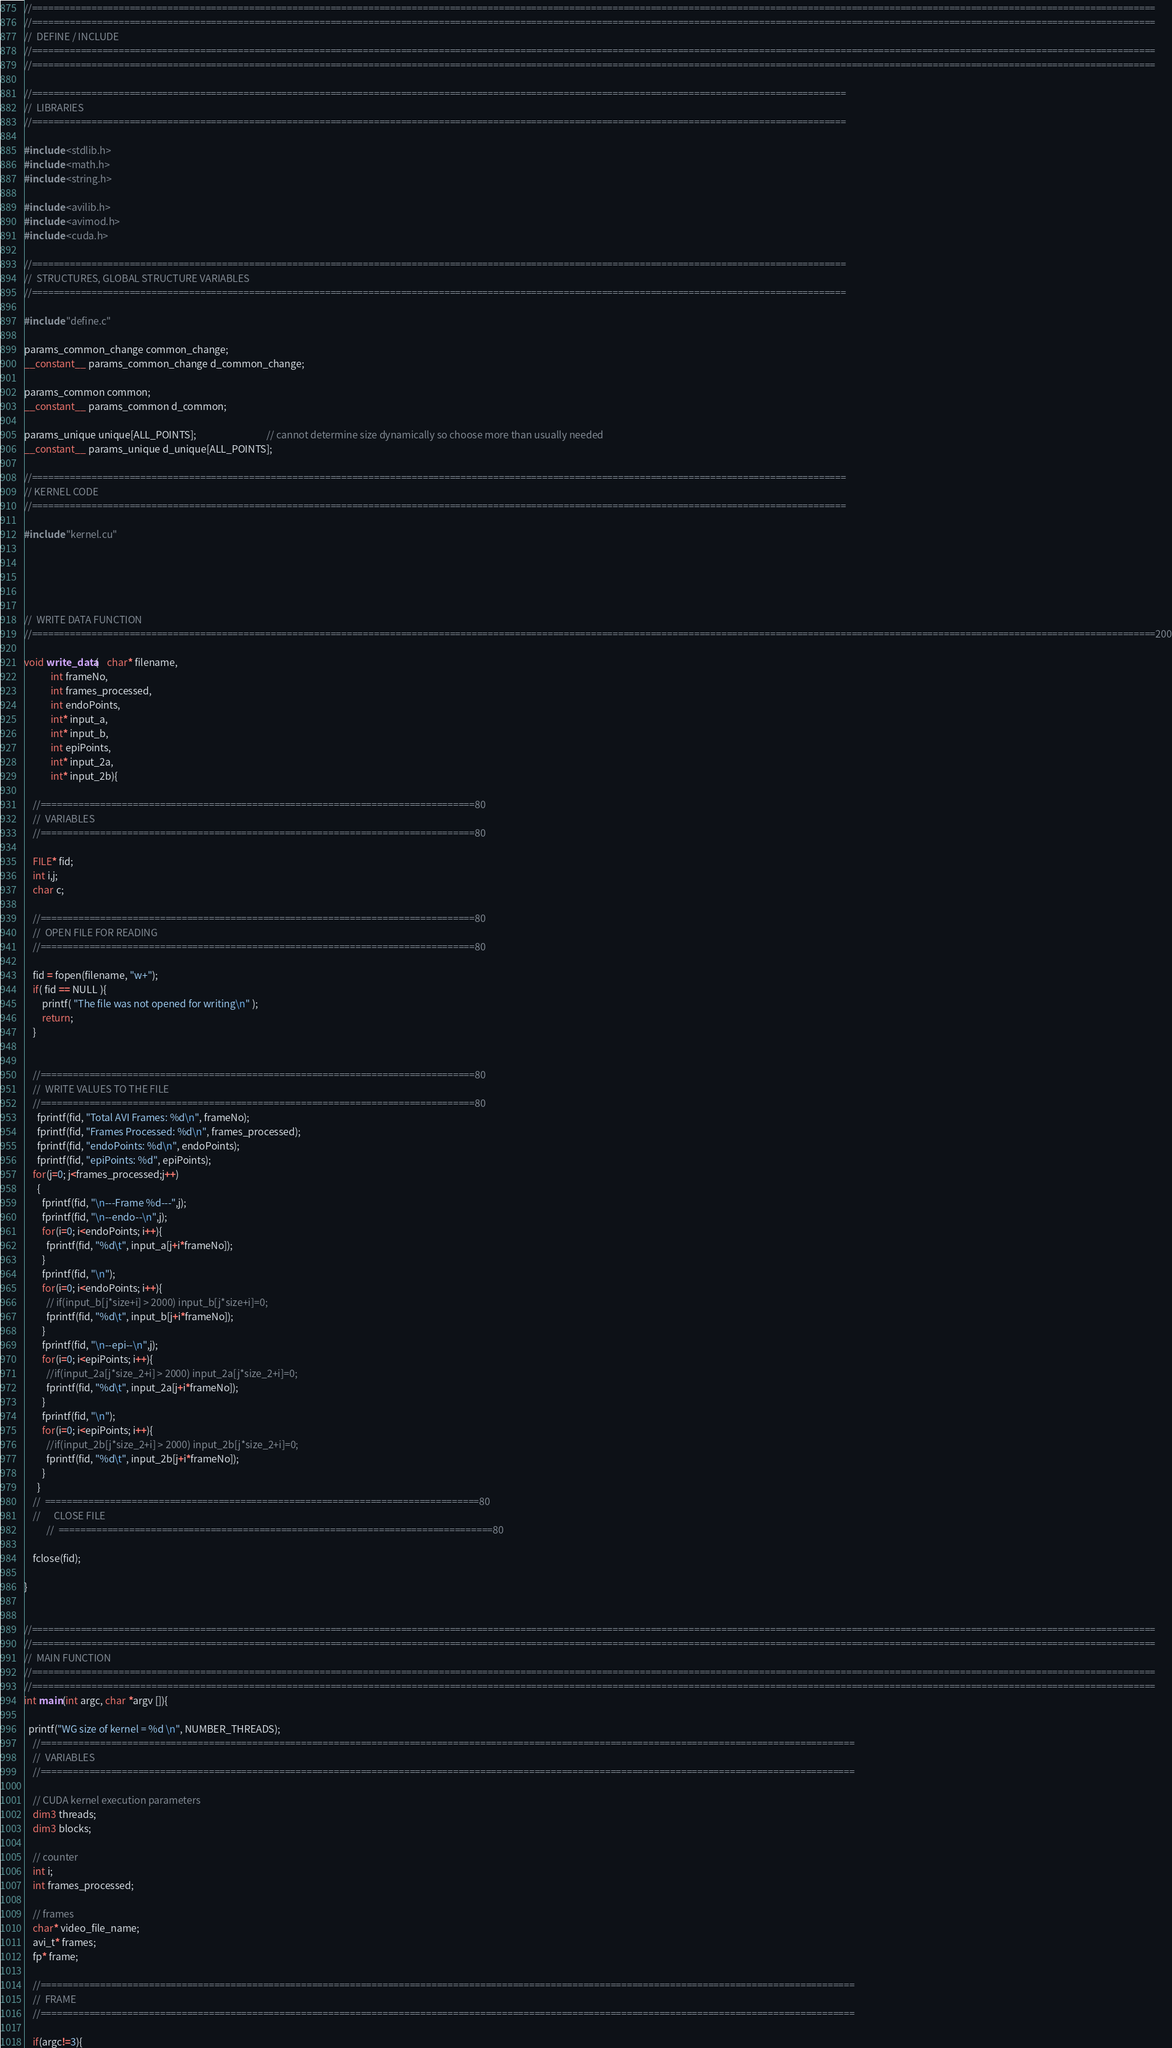Convert code to text. <code><loc_0><loc_0><loc_500><loc_500><_Cuda_>//===============================================================================================================================================================================================================
//===============================================================================================================================================================================================================
//	DEFINE / INCLUDE
//===============================================================================================================================================================================================================
//===============================================================================================================================================================================================================

//======================================================================================================================================================
//	LIBRARIES
//======================================================================================================================================================

#include <stdlib.h>
#include <math.h>
#include <string.h>

#include <avilib.h>
#include <avimod.h>
#include <cuda.h>

//======================================================================================================================================================
//	STRUCTURES, GLOBAL STRUCTURE VARIABLES
//======================================================================================================================================================

#include "define.c"

params_common_change common_change;
__constant__ params_common_change d_common_change;

params_common common;
__constant__ params_common d_common;

params_unique unique[ALL_POINTS];								// cannot determine size dynamically so choose more than usually needed
__constant__ params_unique d_unique[ALL_POINTS];

//======================================================================================================================================================
// KERNEL CODE
//======================================================================================================================================================

#include "kernel.cu"





//	WRITE DATA FUNCTION
//===============================================================================================================================================================================================================200

void write_data(	char* filename,
			int frameNo,
			int frames_processed,
			int endoPoints,
			int* input_a,
			int* input_b,
			int epiPoints,
			int* input_2a,
			int* input_2b){

	//================================================================================80
	//	VARIABLES
	//================================================================================80

	FILE* fid;
	int i,j;
	char c;

	//================================================================================80
	//	OPEN FILE FOR READING
	//================================================================================80

	fid = fopen(filename, "w+");
	if( fid == NULL ){
		printf( "The file was not opened for writing\n" );
		return;
	}


	//================================================================================80
	//	WRITE VALUES TO THE FILE
	//================================================================================80
      fprintf(fid, "Total AVI Frames: %d\n", frameNo);	
      fprintf(fid, "Frames Processed: %d\n", frames_processed);	
      fprintf(fid, "endoPoints: %d\n", endoPoints);
      fprintf(fid, "epiPoints: %d", epiPoints);
	for(j=0; j<frames_processed;j++)
	  {
	    fprintf(fid, "\n---Frame %d---",j);
	    fprintf(fid, "\n--endo--\n",j);
	    for(i=0; i<endoPoints; i++){
	      fprintf(fid, "%d\t", input_a[j+i*frameNo]);
	    }
	    fprintf(fid, "\n");
	    for(i=0; i<endoPoints; i++){
	      // if(input_b[j*size+i] > 2000) input_b[j*size+i]=0;
	      fprintf(fid, "%d\t", input_b[j+i*frameNo]);
	    }
	    fprintf(fid, "\n--epi--\n",j);
	    for(i=0; i<epiPoints; i++){
	      //if(input_2a[j*size_2+i] > 2000) input_2a[j*size_2+i]=0;
	      fprintf(fid, "%d\t", input_2a[j+i*frameNo]);
	    }
	    fprintf(fid, "\n");
	    for(i=0; i<epiPoints; i++){
	      //if(input_2b[j*size_2+i] > 2000) input_2b[j*size_2+i]=0;
	      fprintf(fid, "%d\t", input_2b[j+i*frameNo]);
	    }
	  }
	// 	================================================================================80
	//		CLOSE FILE
		  //	================================================================================80

	fclose(fid);

}


//===============================================================================================================================================================================================================
//===============================================================================================================================================================================================================
//	MAIN FUNCTION
//===============================================================================================================================================================================================================
//===============================================================================================================================================================================================================
int main(int argc, char *argv []){

  printf("WG size of kernel = %d \n", NUMBER_THREADS);
	//======================================================================================================================================================
	//	VARIABLES
	//======================================================================================================================================================

	// CUDA kernel execution parameters
	dim3 threads;
	dim3 blocks;

	// counter
	int i;
	int frames_processed;

	// frames
	char* video_file_name;
	avi_t* frames;
	fp* frame;

	//======================================================================================================================================================
	// 	FRAME
	//======================================================================================================================================================

	if(argc!=3){</code> 